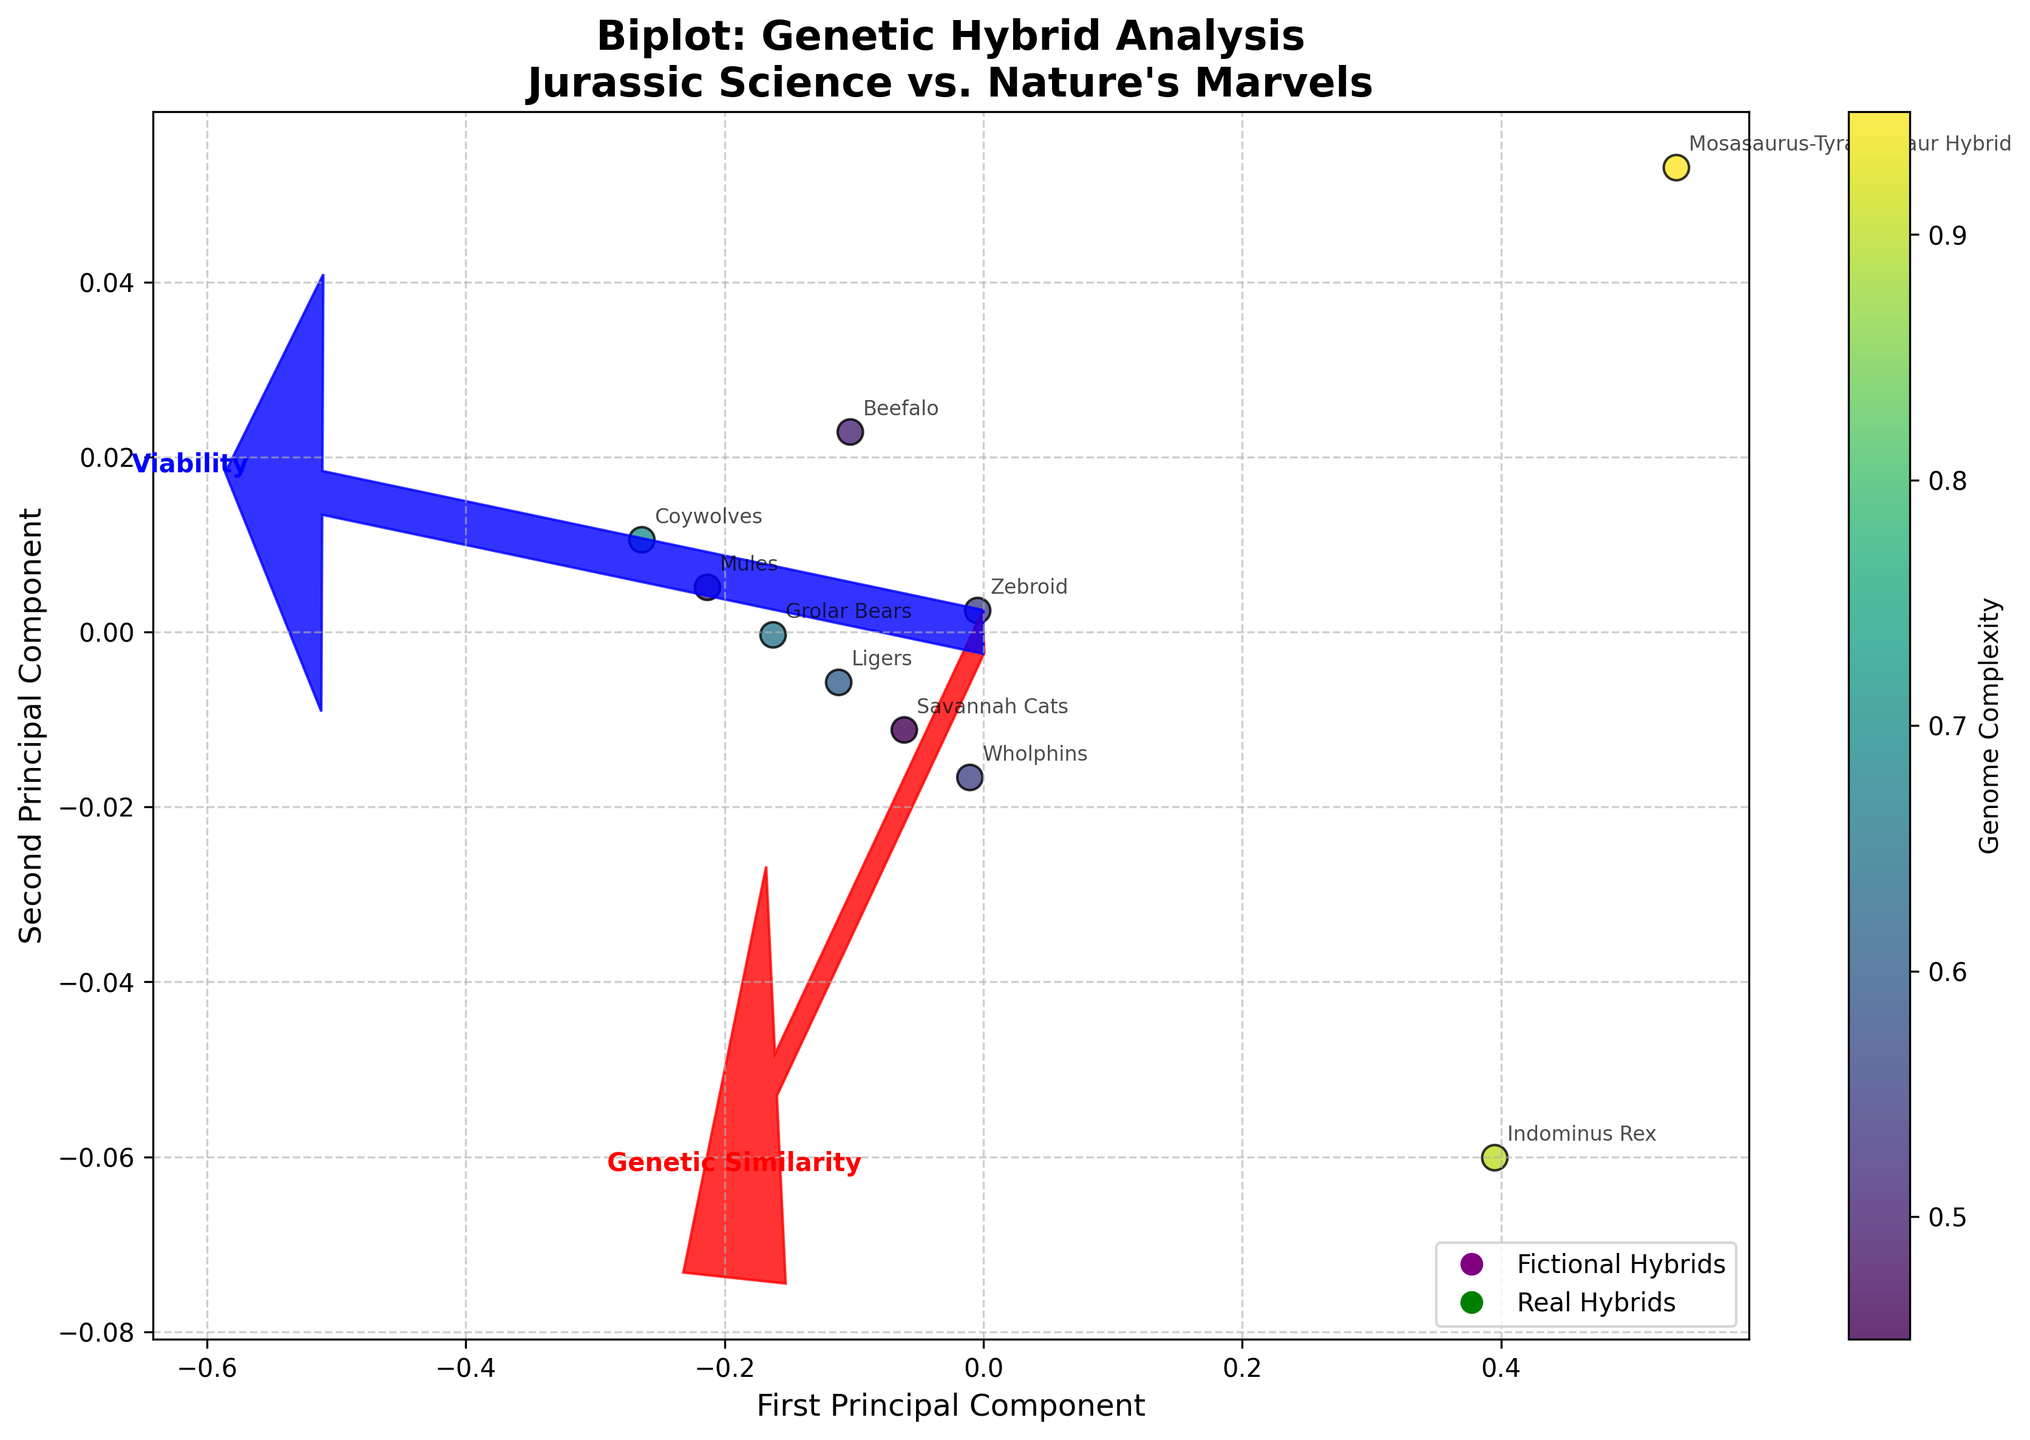What is the title of the plot? The title of the plot is displayed at the top and reads "Biplot: Genetic Hybrid Analysis\nJurassic Science vs. Nature's Marvels."
Answer: Biplot: Genetic Hybrid Analysis\nJurassic Science vs. Nature's Marvels How many data points represent fictional hybrids? There are two fictional hybrids listed in the species data: Indominus Rex and Mosasaurus-Tyrannosaur Hybrid. Thus, there are two purple markers representing fictional hybrids in the plot.
Answer: 2 Which species has the highest viability? To determine this, look at the data points and annotations in the plot. Coywolves have the highest viability value of 0.95.
Answer: Coywolves What feature vectors are shown in the plot? Two feature vectors are shown in the plot: one for "Genetic Similarity" (in red) and one for "Viability" (in blue). Both vectors originate from the center of the plot.
Answer: Genetic Similarity and Viability Which species have identical viability? Checking the annotated data points for their positioning and viability values, both Wholphins and Zebroids have a viability value of 0.7.
Answer: Wholphins and Zebroids How are "Genome Complexity" values represented in the plot? Genome Complexity values are represented by the color shades of the data points, with a colorbar provided to indicate the mapping.
Answer: By color shading Between Ligers and Mules, which has higher genetic similarity and by how much? From the annotated data points, Ligers have a genetic similarity of 0.95 while Mules have 0.97. The difference is 0.97 - 0.95 = 0.02.
Answer: Mules by 0.02 What relationship can you infer between genetic similarity and viability based on the plot? Observing the plot, species with higher viability (e.g., Mules, Coywolves) generally also have high genetic similarity, while species with lower viability (e.g., fictional hybrids) have lower genetic similarity. Thus, there appears to be a positive correlation between genetic similarity and viability.
Answer: Positive correlation Which species is closest to the first principal component's axis origin? By reviewing the projected points in the plot with their annotations, the Beefalo species appears to be closest to the origin.
Answer: Beefalo How do fictional hybrids compare to real hybrids in terms of genetic similarity and viability? Fictional hybrids (purple markers) are located toward the lower ends of both genetic similarity and viability, whereas real hybrids (green markers) generally show higher values for both metrics.
Answer: Lower than real hybrids 